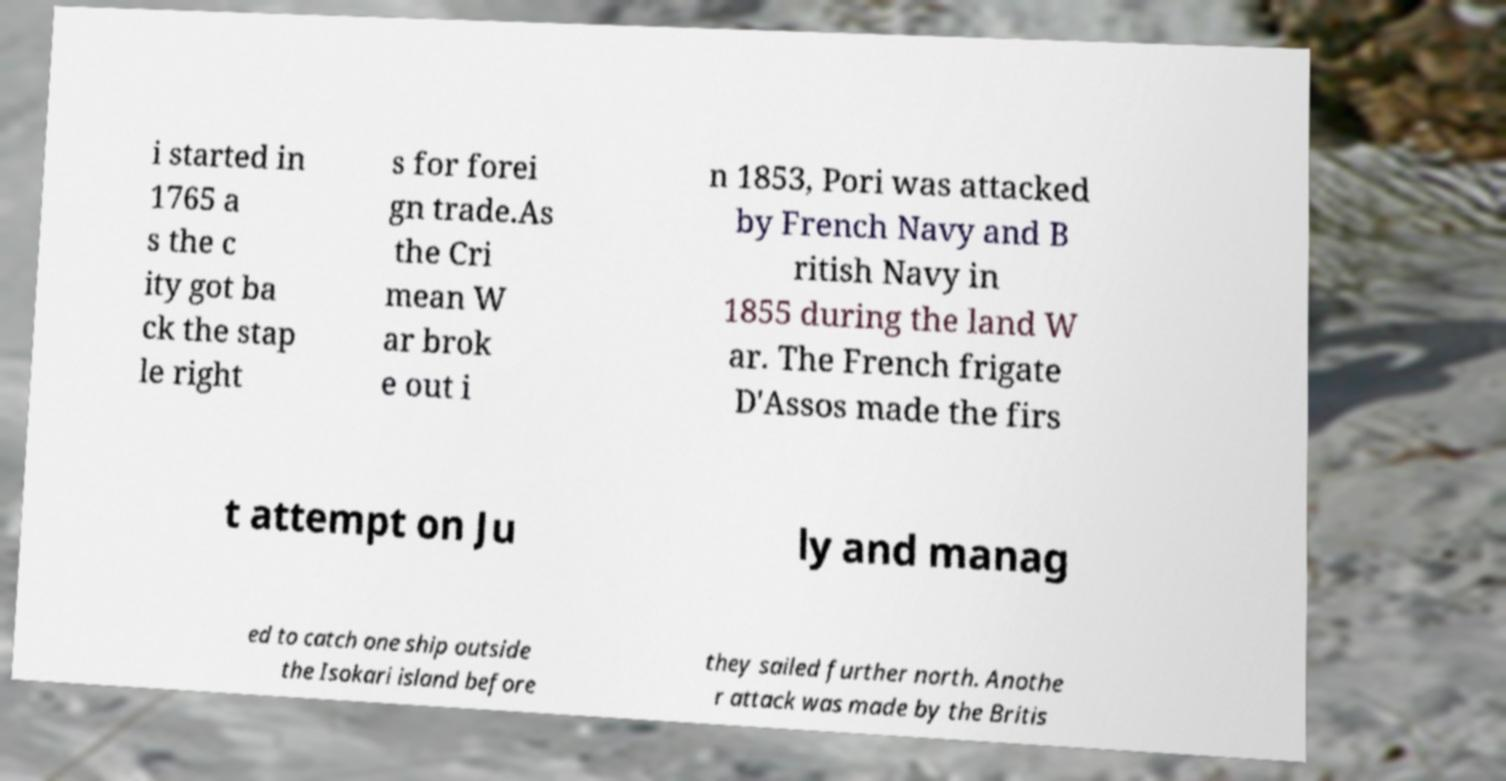I need the written content from this picture converted into text. Can you do that? i started in 1765 a s the c ity got ba ck the stap le right s for forei gn trade.As the Cri mean W ar brok e out i n 1853, Pori was attacked by French Navy and B ritish Navy in 1855 during the land W ar. The French frigate D'Assos made the firs t attempt on Ju ly and manag ed to catch one ship outside the Isokari island before they sailed further north. Anothe r attack was made by the Britis 